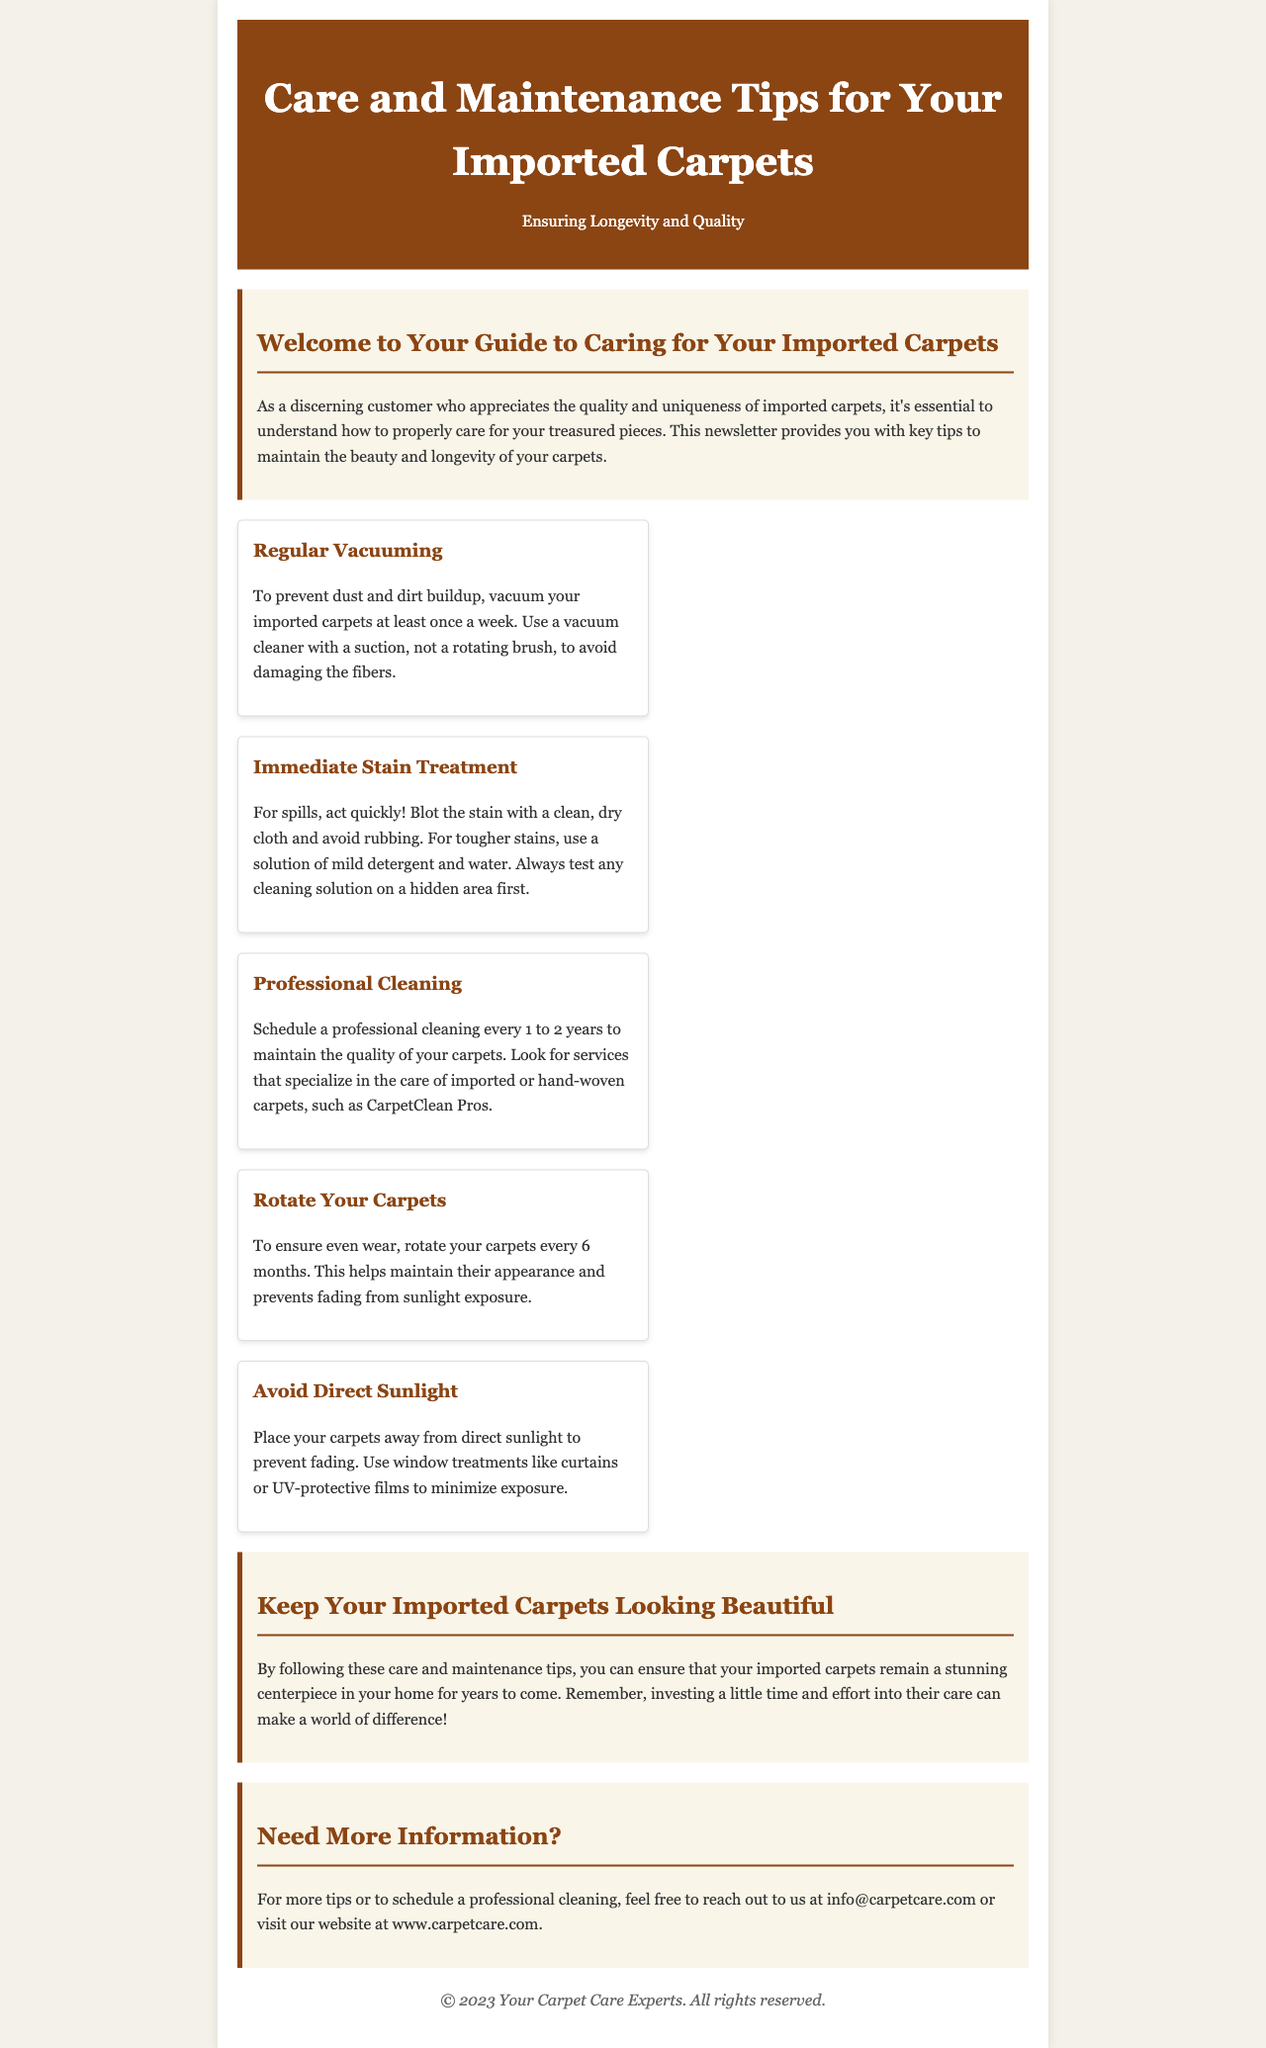What is the title of the newsletter? The title is stated prominently at the top of the document under the header section.
Answer: Care and Maintenance Tips for Your Imported Carpets How often should you vacuum your carpets? The document specifies the frequency of vacuuming to prevent buildup of dust and dirt.
Answer: At least once a week What should you do for immediate stain treatment? The document provides instructions on how to treat stains quickly, highlighting the importance of not rubbing.
Answer: Blot with a clean, dry cloth How long should you wait before scheduling professional cleaning? The document mentions the recommended time frame for professional cleaning services.
Answer: Every 1 to 2 years What does the conclusion emphasize about caring for carpets? The conclusion summarizes the importance of investing time and effort into carpet care.
Answer: Keep your carpets looking beautiful Which company is suggested for professional cleaning services? The document highlights a specific service that specializes in the care of imported carpets.
Answer: CarpetClean Pros How often should you rotate your carpets? The document advises on the frequency of rotating carpets to maintain their condition.
Answer: Every 6 months What is recommended to minimize sunlight exposure? The document suggests a method to prevent carpet fading due to sunlight.
Answer: Use window treatments like curtains or UV-protective films 